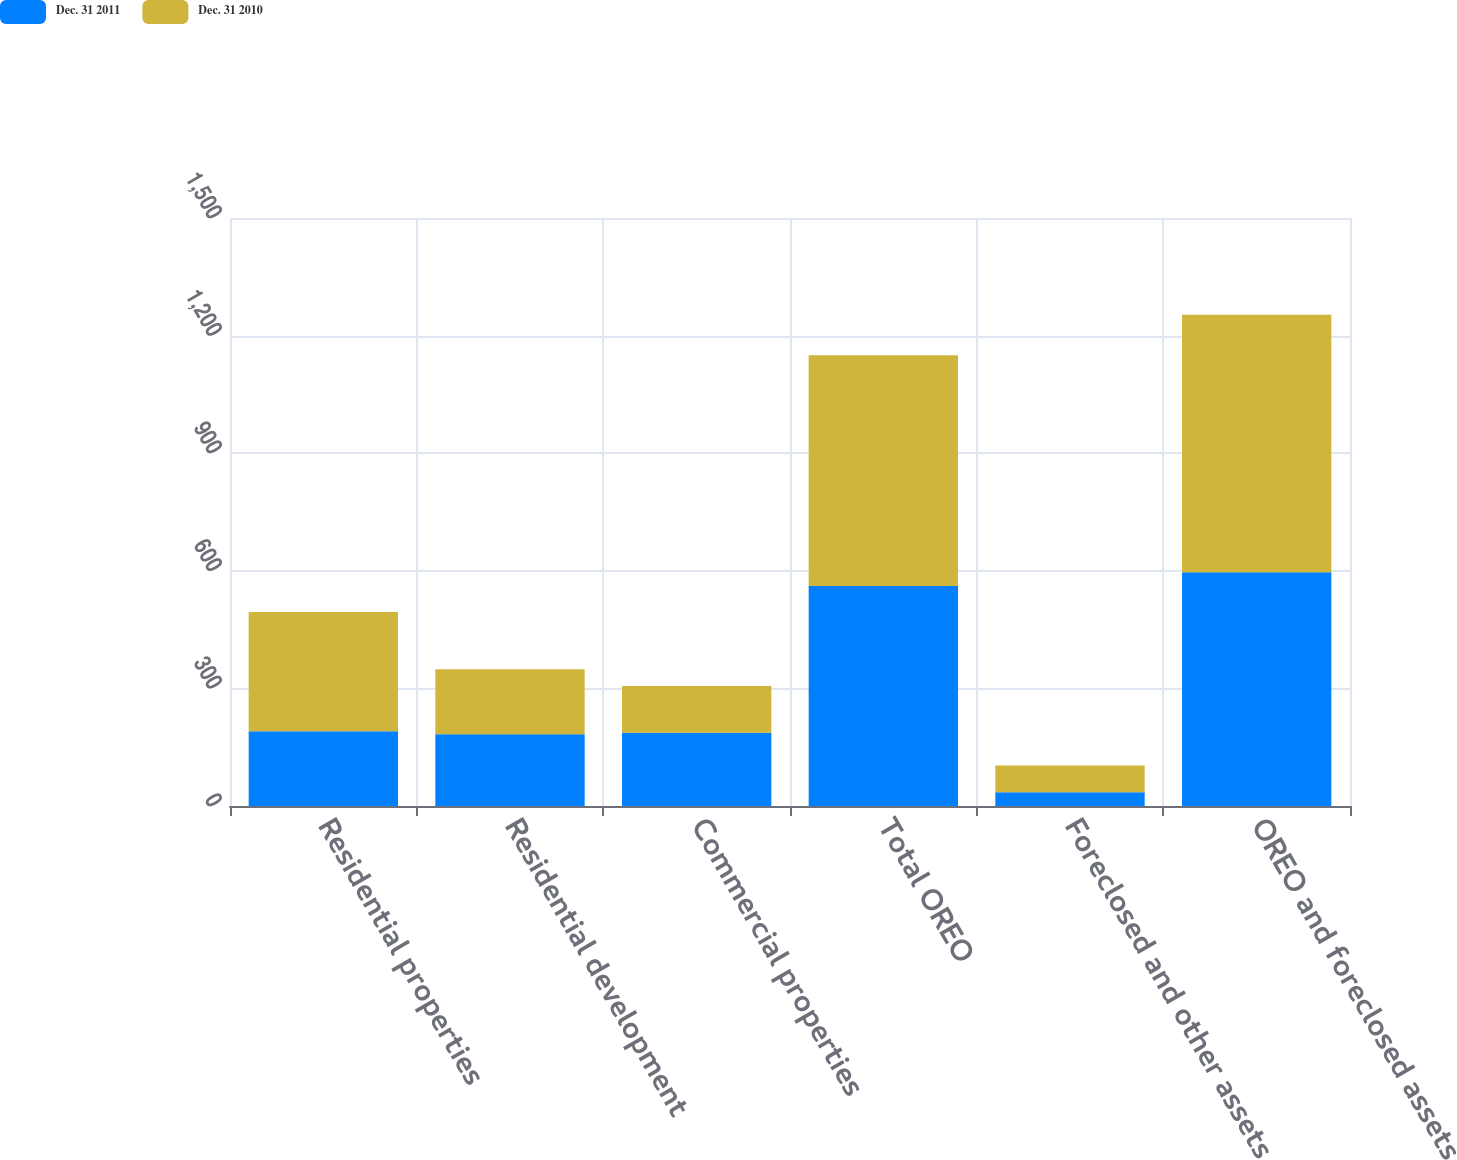Convert chart. <chart><loc_0><loc_0><loc_500><loc_500><stacked_bar_chart><ecel><fcel>Residential properties<fcel>Residential development<fcel>Commercial properties<fcel>Total OREO<fcel>Foreclosed and other assets<fcel>OREO and foreclosed assets<nl><fcel>Dec. 31 2011<fcel>191<fcel>183<fcel>187<fcel>561<fcel>35<fcel>596<nl><fcel>Dec. 31 2010<fcel>304<fcel>166<fcel>119<fcel>589<fcel>68<fcel>657<nl></chart> 